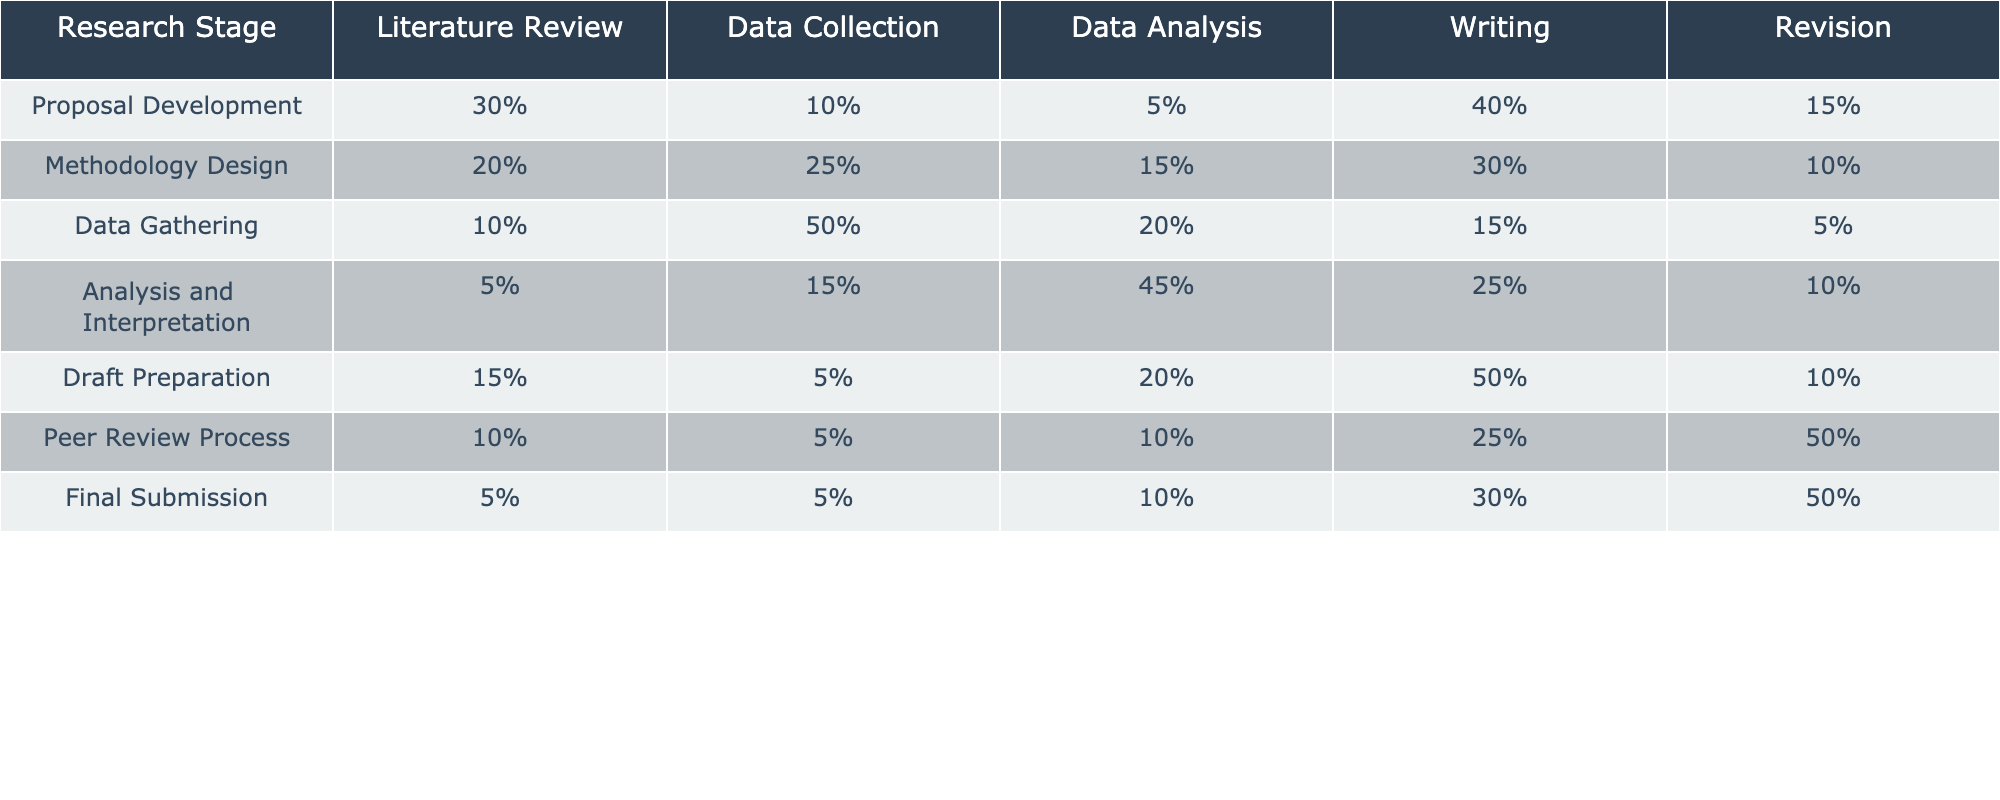What is the percentage allocated to Writing in the Proposal Development stage? In the table, under the Proposal Development stage, the Writing percentage is explicitly listed as 40%.
Answer: 40% Which research stage has the highest percentage allocated to Data Collection? The table shows that Data Gathering has the highest percentage at 50% for Data Collection, compared to other stages where Data Collection values are lower.
Answer: Data Gathering What is the total percentage for Revision across all research stages? To find the total percentage for Revision, we add the Revision percentages from each stage: 15% + 10% + 5% + 10% + 10% + 50% + 50% = 150%.
Answer: 150% In which stage is the least percentage of time allocated to Literature Review? Looking at the Literature Review percentages, Analysis and Interpretation has the least percentage at 5%.
Answer: Analysis and Interpretation What is the average percentage allocated to Writing across all research stages? To find the average, sum the Writing percentages (40% + 30% + 15% + 25% + 50% + 25% + 30%) = 215%. There are 7 stages, so 215% / 7 = 30.71%.
Answer: 30.71% Is it true that more time is allocated to Data Analysis than to Writing in the Data Gathering stage? In the Data Gathering stage, Data Analysis has 20% and Writing has 15%. Therefore, it is true that more time is devoted to Data Analysis.
Answer: Yes What percentage difference in time allocation exists between Writing in the Draft Preparation stage and the highest percentage of Writing across all stages? The highest Writing percentage is 50% in the Draft Preparation stage, and the percentage in Revision for this stage is 10%. The difference is 50% - 10% = 40%.
Answer: 40% Which research stage has the lowest total percentage across all activities? By summing each percentage in each stage, we find that the Final Submission stage has a total of 5% + 5% + 10% + 30% + 50% = 100%, which is the lowest total.
Answer: Final Submission In which research stage is the percentage for Data Analysis equal to 45%? The table indicates that the Analysis and Interpretation stage allocates 45% to Data Analysis.
Answer: Analysis and Interpretation If the Writing percentage in the Peer Review Process was to increase by 5%, what would that new percentage be? The current Writing percentage in the Peer Review Process is 25%. If it increases by 5%, the new percentage would be 25% + 5% = 30%.
Answer: 30% 